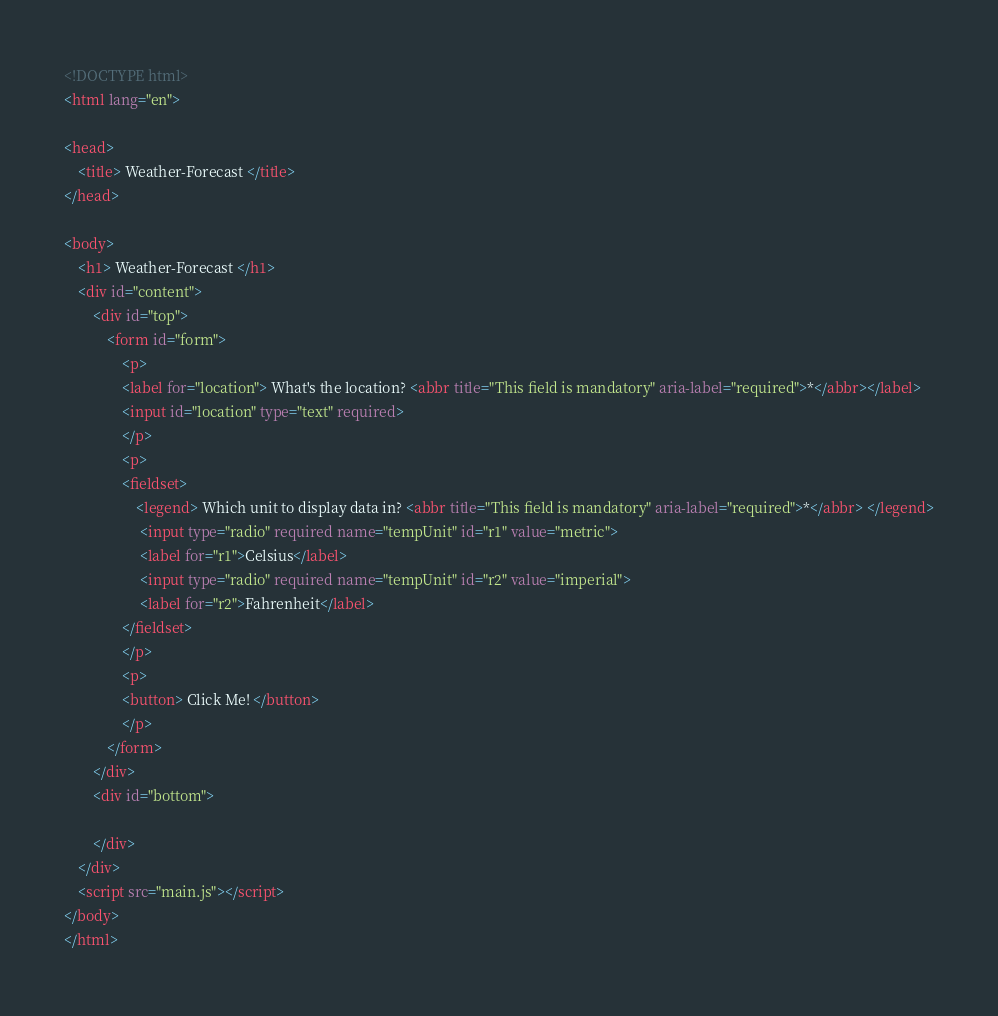Convert code to text. <code><loc_0><loc_0><loc_500><loc_500><_HTML_><!DOCTYPE html>
<html lang="en">

<head>
    <title> Weather-Forecast </title>
</head>

<body>
    <h1> Weather-Forecast </h1>
    <div id="content">
        <div id="top">
            <form id="form">
                <p>
                <label for="location"> What's the location? <abbr title="This field is mandatory" aria-label="required">*</abbr></label>
                <input id="location" type="text" required>
                </p>
                <p>
                <fieldset>
                    <legend> Which unit to display data in? <abbr title="This field is mandatory" aria-label="required">*</abbr> </legend>
                     <input type="radio" required name="tempUnit" id="r1" value="metric">
                     <label for="r1">Celsius</label>
                     <input type="radio" required name="tempUnit" id="r2" value="imperial">
                     <label for="r2">Fahrenheit</label>
                </fieldset>
                </p>
                <p>
                <button> Click Me! </button>
                </p>
            </form>
        </div>
        <div id="bottom">
            
        </div>
    </div>
    <script src="main.js"></script>
</body>
</html></code> 